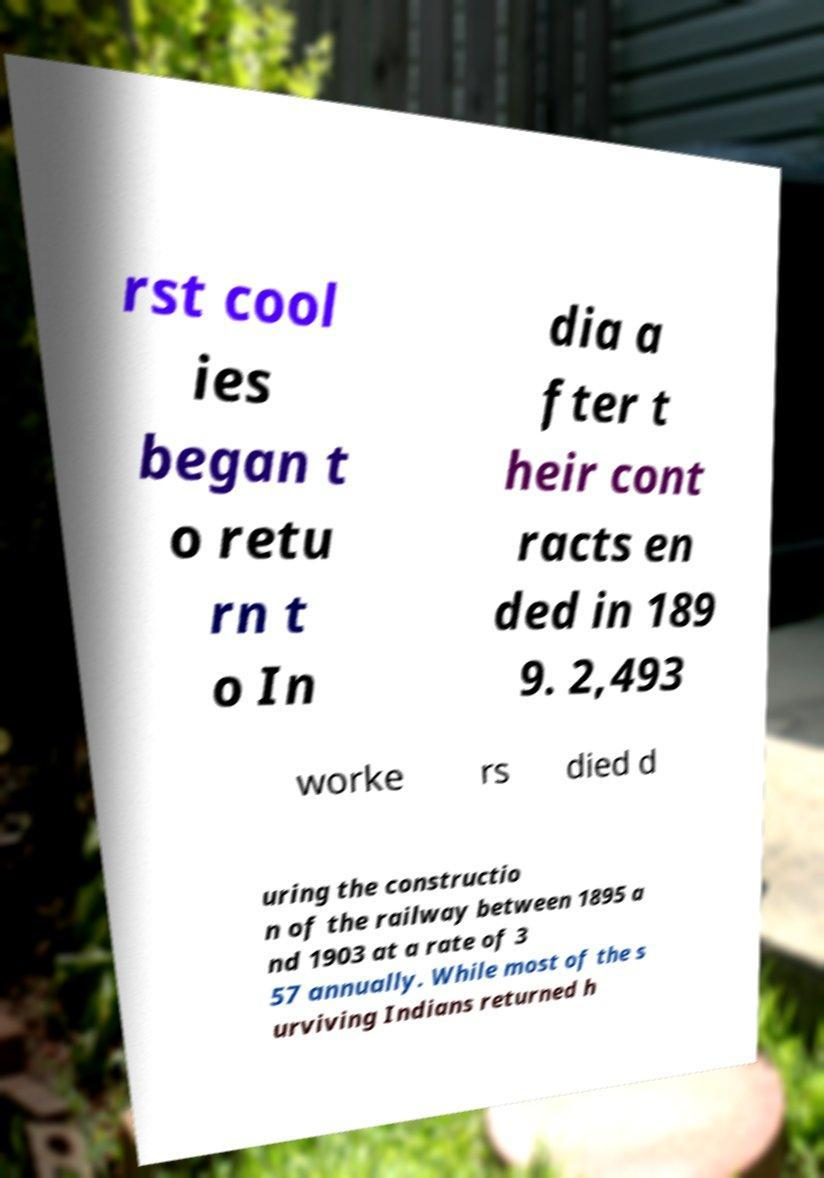For documentation purposes, I need the text within this image transcribed. Could you provide that? rst cool ies began t o retu rn t o In dia a fter t heir cont racts en ded in 189 9. 2,493 worke rs died d uring the constructio n of the railway between 1895 a nd 1903 at a rate of 3 57 annually. While most of the s urviving Indians returned h 